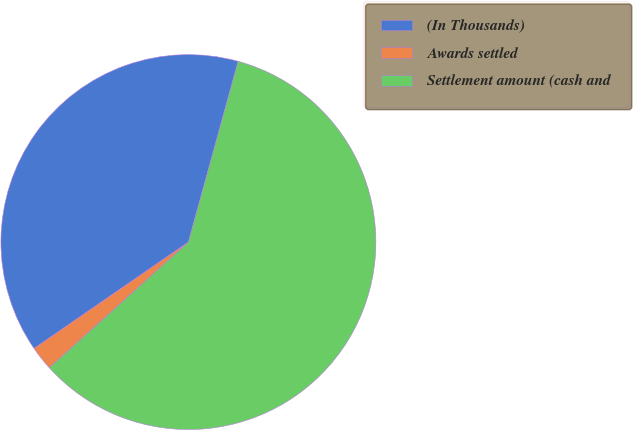Convert chart to OTSL. <chart><loc_0><loc_0><loc_500><loc_500><pie_chart><fcel>(In Thousands)<fcel>Awards settled<fcel>Settlement amount (cash and<nl><fcel>38.88%<fcel>2.09%<fcel>59.04%<nl></chart> 